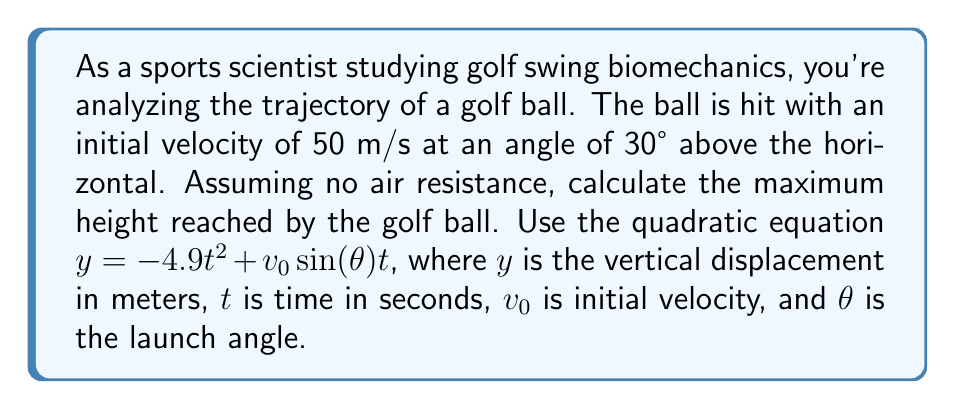Can you answer this question? To find the maximum height, we need to follow these steps:

1) First, let's identify the components of our quadratic equation:
   $y = -4.9t^2 + v_0\sin(\theta)t$
   
   Here, $a = -4.9$, $b = v_0\sin(\theta)$, and $c = 0$

2) Calculate $v_0\sin(\theta)$:
   $v_0\sin(\theta) = 50 \cdot \sin(30°) = 50 \cdot 0.5 = 25$ m/s

3) Our quadratic equation becomes:
   $y = -4.9t^2 + 25t$

4) To find the maximum height, we need to find the vertex of this parabola. The t-coordinate of the vertex is given by $t = -\frac{b}{2a}$:

   $t = -\frac{25}{2(-4.9)} = \frac{25}{9.8} \approx 2.55$ seconds

5) Now we can find the maximum height by plugging this t-value back into our original equation:

   $y_{max} = -4.9(2.55)^2 + 25(2.55)$
   $= -4.9(6.5025) + 63.75$
   $= -31.86225 + 63.75$
   $= 31.88775$ meters

Therefore, the maximum height reached by the golf ball is approximately 31.89 meters.
Answer: 31.89 m 